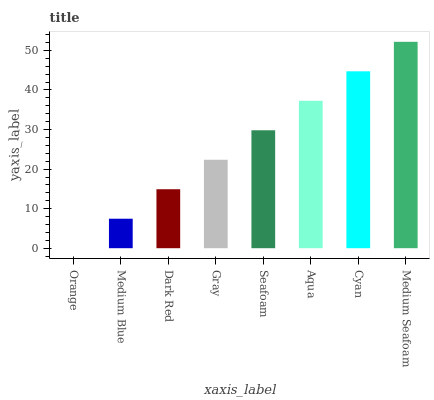Is Orange the minimum?
Answer yes or no. Yes. Is Medium Seafoam the maximum?
Answer yes or no. Yes. Is Medium Blue the minimum?
Answer yes or no. No. Is Medium Blue the maximum?
Answer yes or no. No. Is Medium Blue greater than Orange?
Answer yes or no. Yes. Is Orange less than Medium Blue?
Answer yes or no. Yes. Is Orange greater than Medium Blue?
Answer yes or no. No. Is Medium Blue less than Orange?
Answer yes or no. No. Is Seafoam the high median?
Answer yes or no. Yes. Is Gray the low median?
Answer yes or no. Yes. Is Gray the high median?
Answer yes or no. No. Is Aqua the low median?
Answer yes or no. No. 